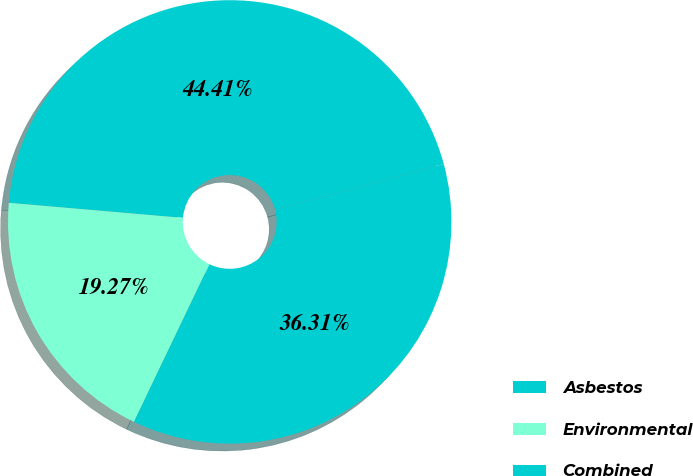Convert chart. <chart><loc_0><loc_0><loc_500><loc_500><pie_chart><fcel>Asbestos<fcel>Environmental<fcel>Combined<nl><fcel>44.41%<fcel>19.27%<fcel>36.31%<nl></chart> 